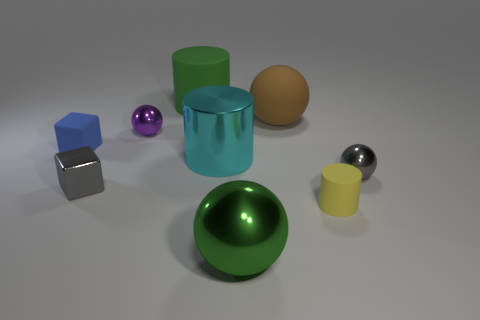Is the color of the big matte cylinder the same as the large metal sphere? yes 